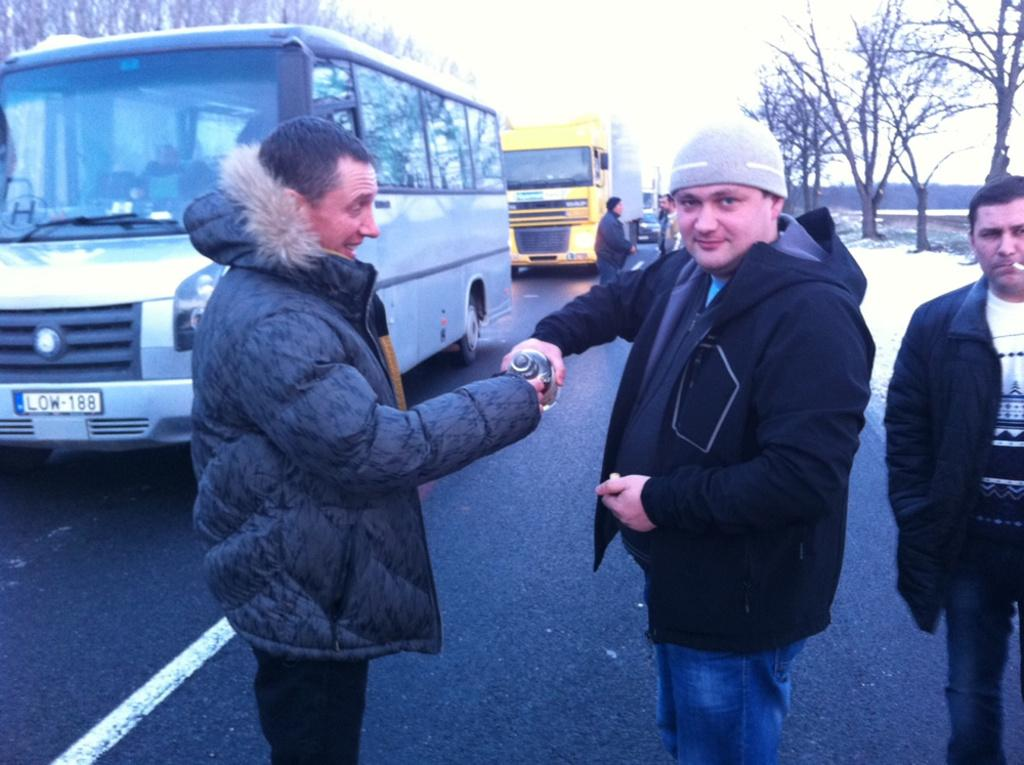Who or what can be seen in the image? There are people in the image. What else is present in the image besides people? There are vehicles on the road and a bottle visible in the image. What can be seen in the background of the image? There are trees and the sky visible in the background of the image. Where is the home located in the image? There is no home present in the image. What type of cracker is being eaten by the people in the image? There is no cracker visible in the image. 